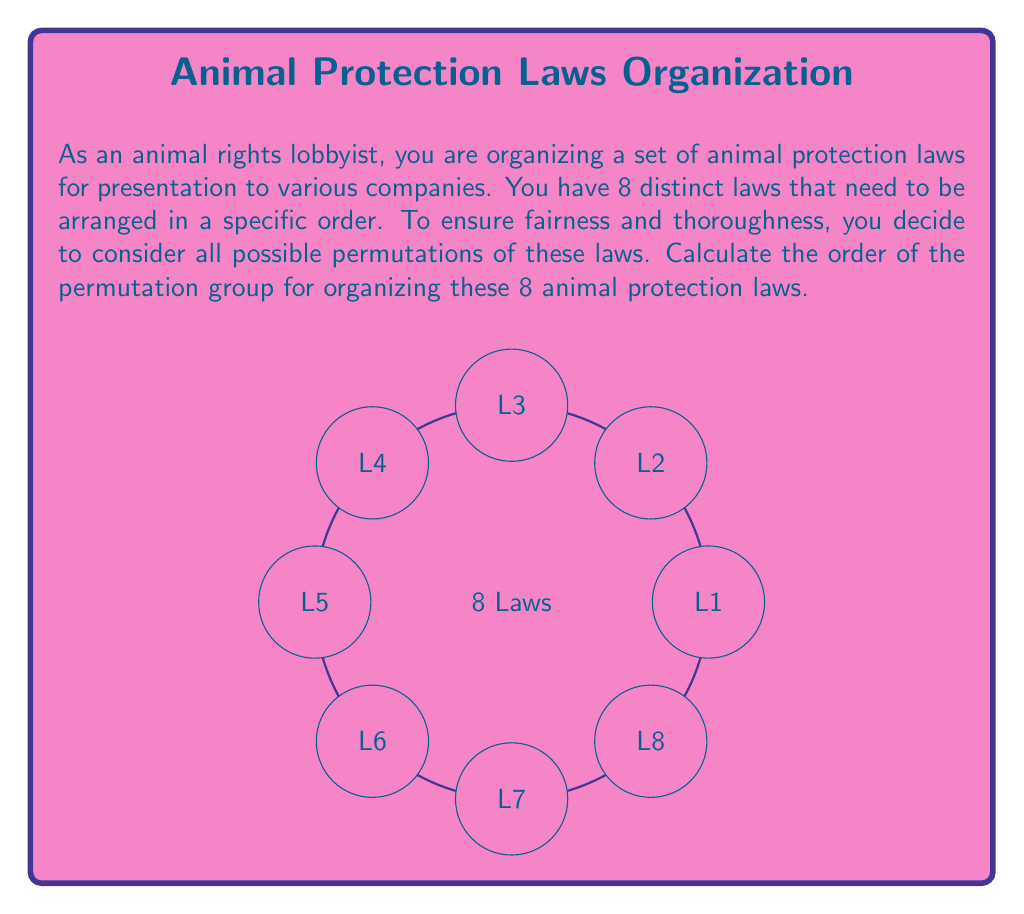Solve this math problem. To calculate the order of the permutation group for organizing 8 animal protection laws, we need to determine the number of possible arrangements (permutations) of these 8 laws.

Step 1: Identify the problem as a permutation.
We are arranging 8 distinct laws, where the order matters and all laws must be used. This is a perfect scenario for calculating permutations.

Step 2: Recall the formula for permutations.
For n distinct objects, the number of permutations is given by n!

Step 3: Apply the formula to our scenario.
In this case, n = 8 (as we have 8 laws)

Step 4: Calculate 8!
$$8! = 8 \times 7 \times 6 \times 5 \times 4 \times 3 \times 2 \times 1 = 40,320$$

Step 5: Interpret the result.
The order of the permutation group is the number of elements in the group, which is equal to the number of possible permutations. Therefore, the order of the permutation group for organizing these 8 animal protection laws is 40,320.

This means there are 40,320 different ways to arrange these 8 laws, and each of these arrangements corresponds to an element in the permutation group $S_8$ (the symmetric group on 8 elements).
Answer: 40,320 